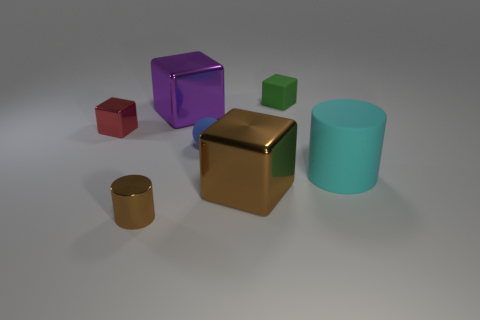Add 2 large blue metallic blocks. How many objects exist? 9 Subtract all gray blocks. Subtract all red cylinders. How many blocks are left? 4 Subtract all spheres. How many objects are left? 6 Subtract all big brown objects. Subtract all tiny brown metal things. How many objects are left? 5 Add 3 big purple shiny cubes. How many big purple shiny cubes are left? 4 Add 1 blue things. How many blue things exist? 2 Subtract 0 gray spheres. How many objects are left? 7 